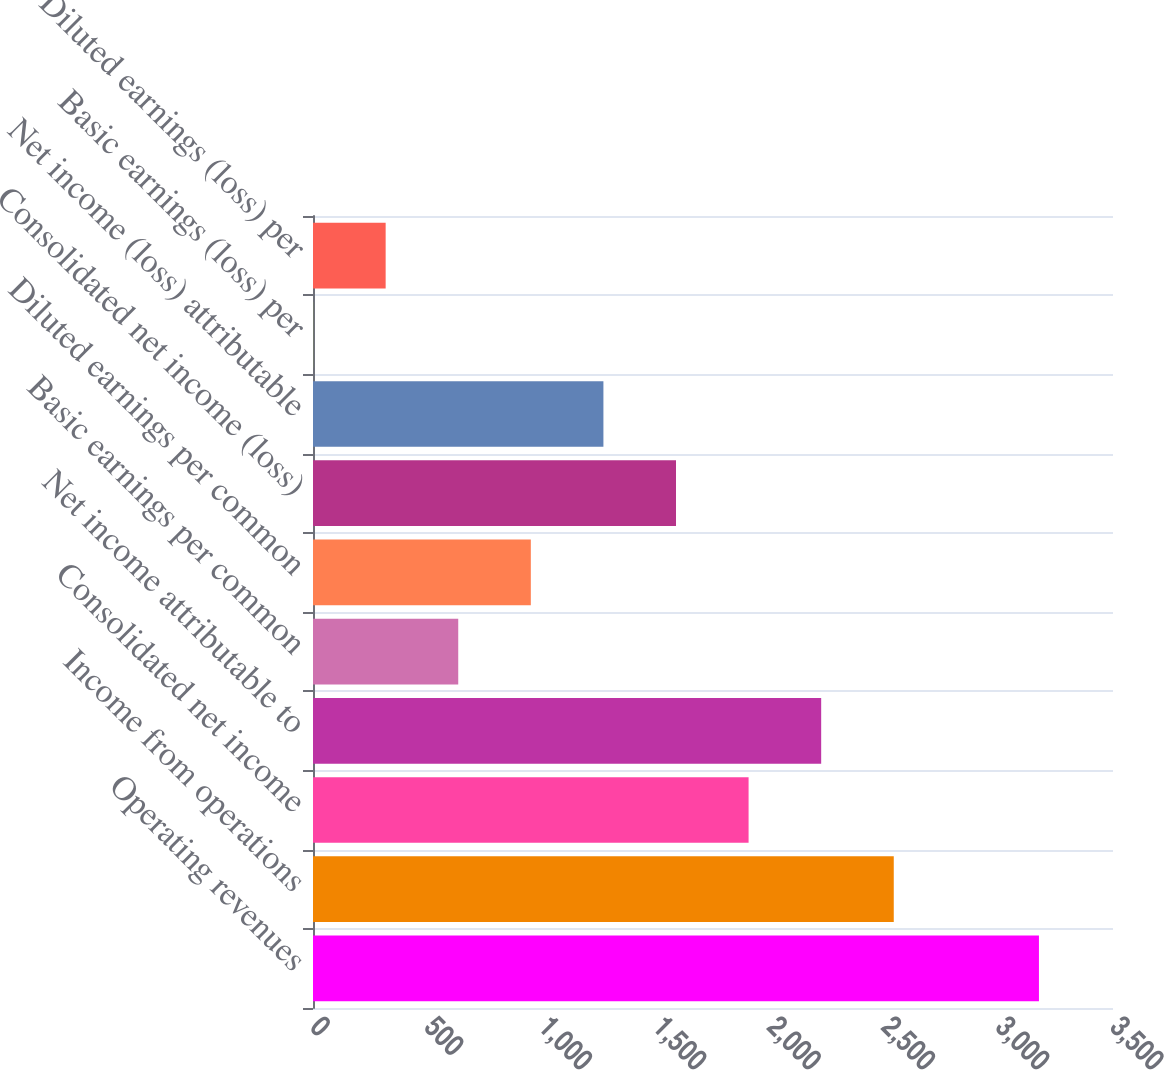<chart> <loc_0><loc_0><loc_500><loc_500><bar_chart><fcel>Operating revenues<fcel>Income from operations<fcel>Consolidated net income<fcel>Net income attributable to<fcel>Basic earnings per common<fcel>Diluted earnings per common<fcel>Consolidated net income (loss)<fcel>Net income (loss) attributable<fcel>Basic earnings (loss) per<fcel>Diluted earnings (loss) per<nl><fcel>3176<fcel>2540.84<fcel>1905.7<fcel>2223.27<fcel>635.42<fcel>952.99<fcel>1588.13<fcel>1270.56<fcel>0.28<fcel>317.85<nl></chart> 